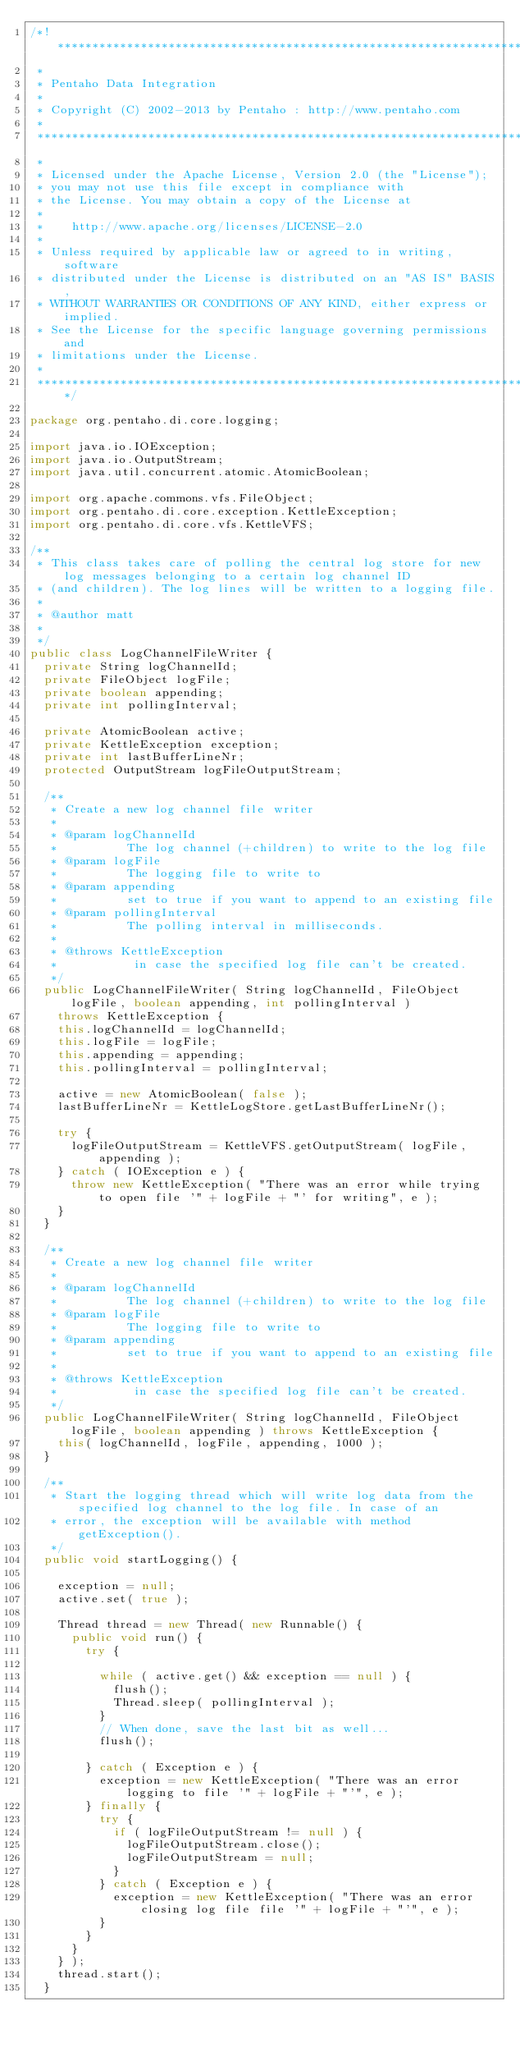<code> <loc_0><loc_0><loc_500><loc_500><_Java_>/*! ******************************************************************************
 *
 * Pentaho Data Integration
 *
 * Copyright (C) 2002-2013 by Pentaho : http://www.pentaho.com
 *
 *******************************************************************************
 *
 * Licensed under the Apache License, Version 2.0 (the "License");
 * you may not use this file except in compliance with
 * the License. You may obtain a copy of the License at
 *
 *    http://www.apache.org/licenses/LICENSE-2.0
 *
 * Unless required by applicable law or agreed to in writing, software
 * distributed under the License is distributed on an "AS IS" BASIS,
 * WITHOUT WARRANTIES OR CONDITIONS OF ANY KIND, either express or implied.
 * See the License for the specific language governing permissions and
 * limitations under the License.
 *
 ******************************************************************************/

package org.pentaho.di.core.logging;

import java.io.IOException;
import java.io.OutputStream;
import java.util.concurrent.atomic.AtomicBoolean;

import org.apache.commons.vfs.FileObject;
import org.pentaho.di.core.exception.KettleException;
import org.pentaho.di.core.vfs.KettleVFS;

/**
 * This class takes care of polling the central log store for new log messages belonging to a certain log channel ID
 * (and children). The log lines will be written to a logging file.
 * 
 * @author matt
 * 
 */
public class LogChannelFileWriter {
  private String logChannelId;
  private FileObject logFile;
  private boolean appending;
  private int pollingInterval;

  private AtomicBoolean active;
  private KettleException exception;
  private int lastBufferLineNr;
  protected OutputStream logFileOutputStream;

  /**
   * Create a new log channel file writer
   * 
   * @param logChannelId
   *          The log channel (+children) to write to the log file
   * @param logFile
   *          The logging file to write to
   * @param appending
   *          set to true if you want to append to an existing file
   * @param pollingInterval
   *          The polling interval in milliseconds.
   * 
   * @throws KettleException
   *           in case the specified log file can't be created.
   */
  public LogChannelFileWriter( String logChannelId, FileObject logFile, boolean appending, int pollingInterval )
    throws KettleException {
    this.logChannelId = logChannelId;
    this.logFile = logFile;
    this.appending = appending;
    this.pollingInterval = pollingInterval;

    active = new AtomicBoolean( false );
    lastBufferLineNr = KettleLogStore.getLastBufferLineNr();

    try {
      logFileOutputStream = KettleVFS.getOutputStream( logFile, appending );
    } catch ( IOException e ) {
      throw new KettleException( "There was an error while trying to open file '" + logFile + "' for writing", e );
    }
  }

  /**
   * Create a new log channel file writer
   * 
   * @param logChannelId
   *          The log channel (+children) to write to the log file
   * @param logFile
   *          The logging file to write to
   * @param appending
   *          set to true if you want to append to an existing file
   * 
   * @throws KettleException
   *           in case the specified log file can't be created.
   */
  public LogChannelFileWriter( String logChannelId, FileObject logFile, boolean appending ) throws KettleException {
    this( logChannelId, logFile, appending, 1000 );
  }

  /**
   * Start the logging thread which will write log data from the specified log channel to the log file. In case of an
   * error, the exception will be available with method getException().
   */
  public void startLogging() {

    exception = null;
    active.set( true );

    Thread thread = new Thread( new Runnable() {
      public void run() {
        try {

          while ( active.get() && exception == null ) {
            flush();
            Thread.sleep( pollingInterval );
          }
          // When done, save the last bit as well...
          flush();

        } catch ( Exception e ) {
          exception = new KettleException( "There was an error logging to file '" + logFile + "'", e );
        } finally {
          try {
            if ( logFileOutputStream != null ) {
              logFileOutputStream.close();
              logFileOutputStream = null;
            }
          } catch ( Exception e ) {
            exception = new KettleException( "There was an error closing log file file '" + logFile + "'", e );
          }
        }
      }
    } );
    thread.start();
  }
</code> 